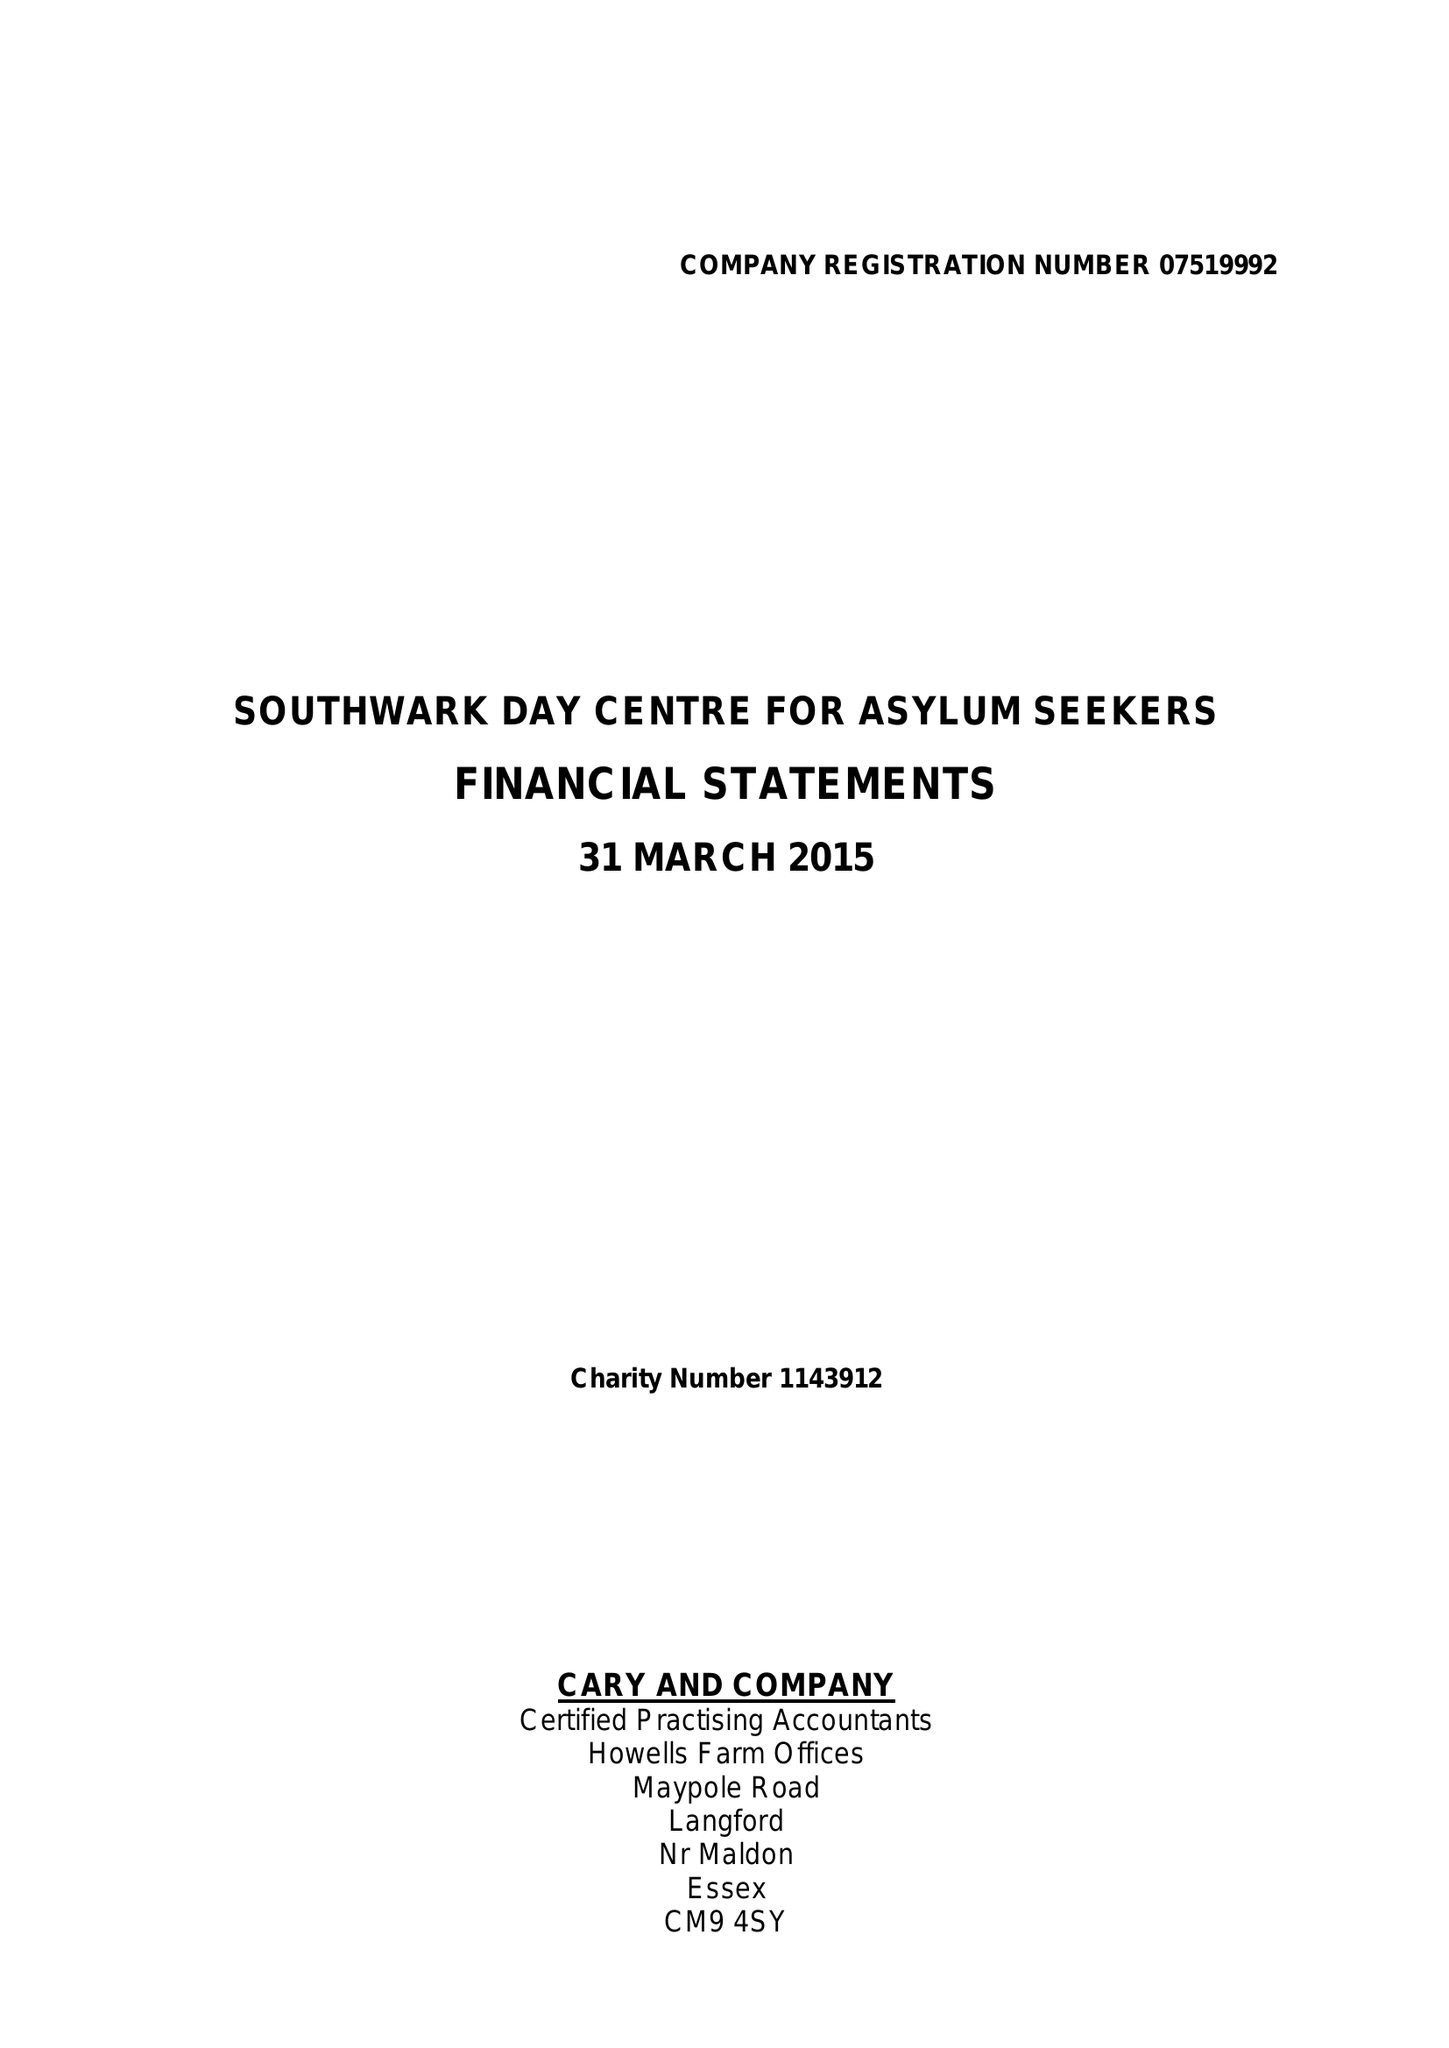What is the value for the address__street_line?
Answer the question using a single word or phrase. None 